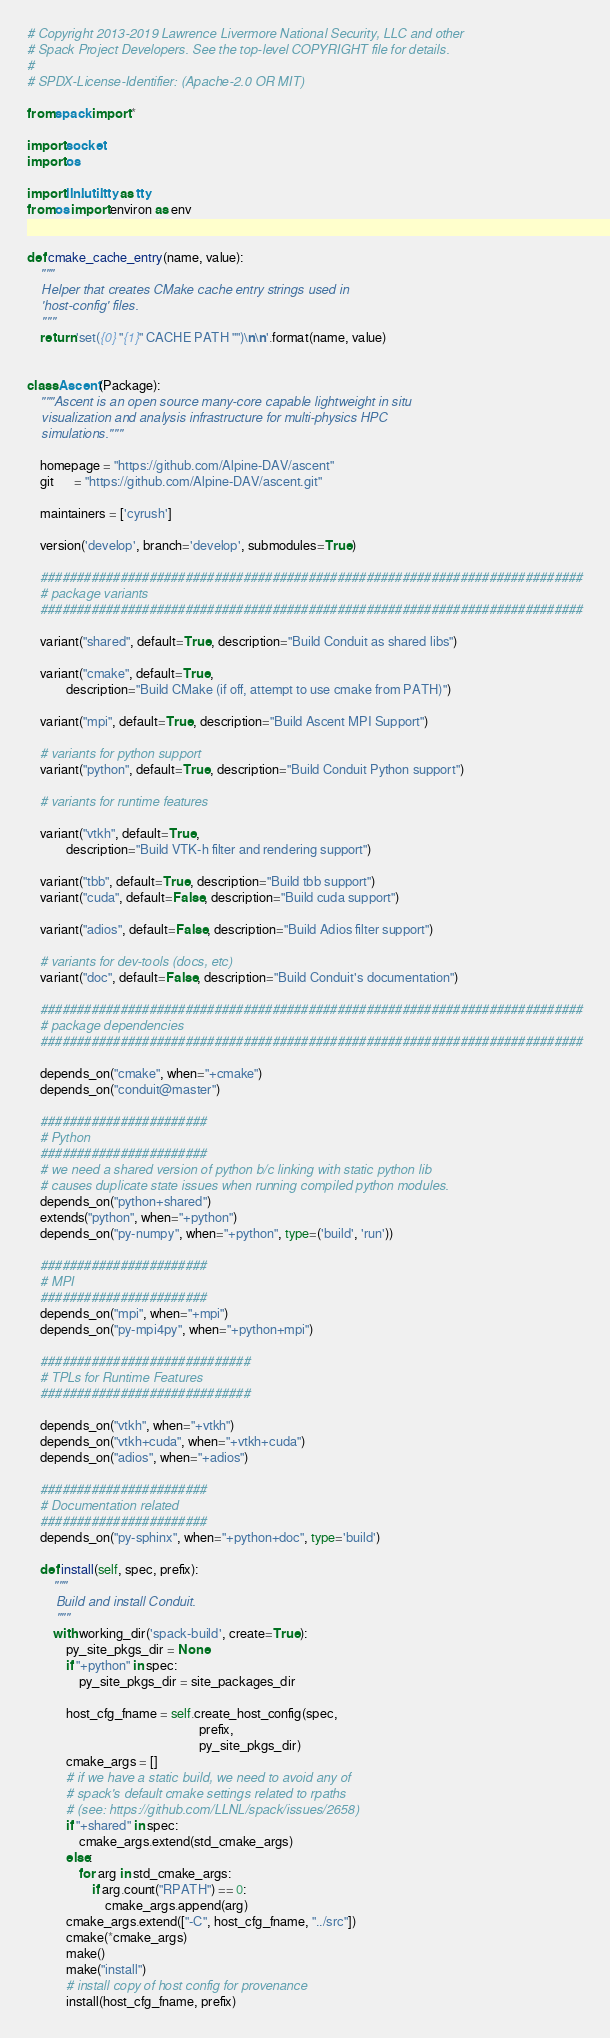<code> <loc_0><loc_0><loc_500><loc_500><_Python_># Copyright 2013-2019 Lawrence Livermore National Security, LLC and other
# Spack Project Developers. See the top-level COPYRIGHT file for details.
#
# SPDX-License-Identifier: (Apache-2.0 OR MIT)

from spack import *

import socket
import os

import llnl.util.tty as tty
from os import environ as env


def cmake_cache_entry(name, value):
    """
    Helper that creates CMake cache entry strings used in
    'host-config' files.
    """
    return 'set({0} "{1}" CACHE PATH "")\n\n'.format(name, value)


class Ascent(Package):
    """Ascent is an open source many-core capable lightweight in situ
    visualization and analysis infrastructure for multi-physics HPC
    simulations."""

    homepage = "https://github.com/Alpine-DAV/ascent"
    git      = "https://github.com/Alpine-DAV/ascent.git"

    maintainers = ['cyrush']

    version('develop', branch='develop', submodules=True)

    ###########################################################################
    # package variants
    ###########################################################################

    variant("shared", default=True, description="Build Conduit as shared libs")

    variant("cmake", default=True,
            description="Build CMake (if off, attempt to use cmake from PATH)")

    variant("mpi", default=True, description="Build Ascent MPI Support")

    # variants for python support
    variant("python", default=True, description="Build Conduit Python support")

    # variants for runtime features

    variant("vtkh", default=True,
            description="Build VTK-h filter and rendering support")

    variant("tbb", default=True, description="Build tbb support")
    variant("cuda", default=False, description="Build cuda support")

    variant("adios", default=False, description="Build Adios filter support")

    # variants for dev-tools (docs, etc)
    variant("doc", default=False, description="Build Conduit's documentation")

    ###########################################################################
    # package dependencies
    ###########################################################################

    depends_on("cmake", when="+cmake")
    depends_on("conduit@master")

    #######################
    # Python
    #######################
    # we need a shared version of python b/c linking with static python lib
    # causes duplicate state issues when running compiled python modules.
    depends_on("python+shared")
    extends("python", when="+python")
    depends_on("py-numpy", when="+python", type=('build', 'run'))

    #######################
    # MPI
    #######################
    depends_on("mpi", when="+mpi")
    depends_on("py-mpi4py", when="+python+mpi")

    #############################
    # TPLs for Runtime Features
    #############################

    depends_on("vtkh", when="+vtkh")
    depends_on("vtkh+cuda", when="+vtkh+cuda")
    depends_on("adios", when="+adios")

    #######################
    # Documentation related
    #######################
    depends_on("py-sphinx", when="+python+doc", type='build')

    def install(self, spec, prefix):
        """
        Build and install Conduit.
        """
        with working_dir('spack-build', create=True):
            py_site_pkgs_dir = None
            if "+python" in spec:
                py_site_pkgs_dir = site_packages_dir

            host_cfg_fname = self.create_host_config(spec,
                                                     prefix,
                                                     py_site_pkgs_dir)
            cmake_args = []
            # if we have a static build, we need to avoid any of
            # spack's default cmake settings related to rpaths
            # (see: https://github.com/LLNL/spack/issues/2658)
            if "+shared" in spec:
                cmake_args.extend(std_cmake_args)
            else:
                for arg in std_cmake_args:
                    if arg.count("RPATH") == 0:
                        cmake_args.append(arg)
            cmake_args.extend(["-C", host_cfg_fname, "../src"])
            cmake(*cmake_args)
            make()
            make("install")
            # install copy of host config for provenance
            install(host_cfg_fname, prefix)
</code> 